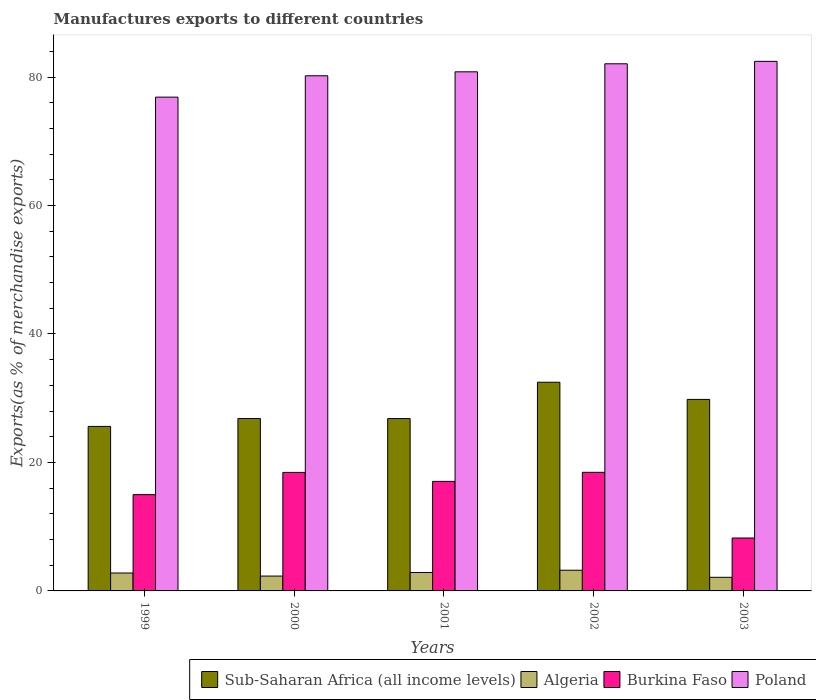Are the number of bars on each tick of the X-axis equal?
Keep it short and to the point. Yes. How many bars are there on the 1st tick from the left?
Ensure brevity in your answer.  4. In how many cases, is the number of bars for a given year not equal to the number of legend labels?
Your answer should be compact. 0. What is the percentage of exports to different countries in Poland in 2003?
Ensure brevity in your answer.  82.44. Across all years, what is the maximum percentage of exports to different countries in Burkina Faso?
Give a very brief answer. 18.46. Across all years, what is the minimum percentage of exports to different countries in Burkina Faso?
Your response must be concise. 8.24. What is the total percentage of exports to different countries in Sub-Saharan Africa (all income levels) in the graph?
Give a very brief answer. 141.58. What is the difference between the percentage of exports to different countries in Sub-Saharan Africa (all income levels) in 2001 and that in 2002?
Your response must be concise. -5.65. What is the difference between the percentage of exports to different countries in Poland in 2000 and the percentage of exports to different countries in Burkina Faso in 2001?
Provide a succinct answer. 63.14. What is the average percentage of exports to different countries in Poland per year?
Make the answer very short. 80.47. In the year 2001, what is the difference between the percentage of exports to different countries in Sub-Saharan Africa (all income levels) and percentage of exports to different countries in Algeria?
Offer a very short reply. 23.96. In how many years, is the percentage of exports to different countries in Poland greater than 28 %?
Offer a terse response. 5. What is the ratio of the percentage of exports to different countries in Poland in 1999 to that in 2003?
Make the answer very short. 0.93. Is the difference between the percentage of exports to different countries in Sub-Saharan Africa (all income levels) in 1999 and 2003 greater than the difference between the percentage of exports to different countries in Algeria in 1999 and 2003?
Ensure brevity in your answer.  No. What is the difference between the highest and the second highest percentage of exports to different countries in Sub-Saharan Africa (all income levels)?
Provide a succinct answer. 2.67. What is the difference between the highest and the lowest percentage of exports to different countries in Poland?
Keep it short and to the point. 5.57. Is the sum of the percentage of exports to different countries in Burkina Faso in 1999 and 2003 greater than the maximum percentage of exports to different countries in Sub-Saharan Africa (all income levels) across all years?
Your response must be concise. No. Is it the case that in every year, the sum of the percentage of exports to different countries in Burkina Faso and percentage of exports to different countries in Algeria is greater than the sum of percentage of exports to different countries in Poland and percentage of exports to different countries in Sub-Saharan Africa (all income levels)?
Keep it short and to the point. Yes. What does the 2nd bar from the left in 2003 represents?
Keep it short and to the point. Algeria. What does the 4th bar from the right in 2001 represents?
Ensure brevity in your answer.  Sub-Saharan Africa (all income levels). Is it the case that in every year, the sum of the percentage of exports to different countries in Sub-Saharan Africa (all income levels) and percentage of exports to different countries in Poland is greater than the percentage of exports to different countries in Burkina Faso?
Ensure brevity in your answer.  Yes. Are all the bars in the graph horizontal?
Your answer should be compact. No. How many years are there in the graph?
Your answer should be very brief. 5. Are the values on the major ticks of Y-axis written in scientific E-notation?
Give a very brief answer. No. Does the graph contain grids?
Keep it short and to the point. No. Where does the legend appear in the graph?
Offer a terse response. Bottom right. How many legend labels are there?
Give a very brief answer. 4. How are the legend labels stacked?
Offer a terse response. Horizontal. What is the title of the graph?
Give a very brief answer. Manufactures exports to different countries. What is the label or title of the Y-axis?
Make the answer very short. Exports(as % of merchandise exports). What is the Exports(as % of merchandise exports) in Sub-Saharan Africa (all income levels) in 1999?
Keep it short and to the point. 25.61. What is the Exports(as % of merchandise exports) in Algeria in 1999?
Offer a terse response. 2.79. What is the Exports(as % of merchandise exports) in Burkina Faso in 1999?
Keep it short and to the point. 14.98. What is the Exports(as % of merchandise exports) in Poland in 1999?
Your answer should be compact. 76.87. What is the Exports(as % of merchandise exports) in Sub-Saharan Africa (all income levels) in 2000?
Your answer should be very brief. 26.84. What is the Exports(as % of merchandise exports) in Algeria in 2000?
Provide a succinct answer. 2.31. What is the Exports(as % of merchandise exports) in Burkina Faso in 2000?
Offer a terse response. 18.45. What is the Exports(as % of merchandise exports) in Poland in 2000?
Your answer should be compact. 80.19. What is the Exports(as % of merchandise exports) of Sub-Saharan Africa (all income levels) in 2001?
Give a very brief answer. 26.83. What is the Exports(as % of merchandise exports) in Algeria in 2001?
Provide a short and direct response. 2.87. What is the Exports(as % of merchandise exports) of Burkina Faso in 2001?
Ensure brevity in your answer.  17.05. What is the Exports(as % of merchandise exports) in Poland in 2001?
Provide a short and direct response. 80.81. What is the Exports(as % of merchandise exports) of Sub-Saharan Africa (all income levels) in 2002?
Offer a terse response. 32.48. What is the Exports(as % of merchandise exports) of Algeria in 2002?
Provide a succinct answer. 3.22. What is the Exports(as % of merchandise exports) in Burkina Faso in 2002?
Offer a terse response. 18.46. What is the Exports(as % of merchandise exports) in Poland in 2002?
Provide a succinct answer. 82.06. What is the Exports(as % of merchandise exports) in Sub-Saharan Africa (all income levels) in 2003?
Ensure brevity in your answer.  29.81. What is the Exports(as % of merchandise exports) of Algeria in 2003?
Your answer should be compact. 2.12. What is the Exports(as % of merchandise exports) in Burkina Faso in 2003?
Offer a terse response. 8.24. What is the Exports(as % of merchandise exports) in Poland in 2003?
Keep it short and to the point. 82.44. Across all years, what is the maximum Exports(as % of merchandise exports) in Sub-Saharan Africa (all income levels)?
Provide a short and direct response. 32.48. Across all years, what is the maximum Exports(as % of merchandise exports) of Algeria?
Offer a terse response. 3.22. Across all years, what is the maximum Exports(as % of merchandise exports) of Burkina Faso?
Ensure brevity in your answer.  18.46. Across all years, what is the maximum Exports(as % of merchandise exports) in Poland?
Offer a terse response. 82.44. Across all years, what is the minimum Exports(as % of merchandise exports) in Sub-Saharan Africa (all income levels)?
Give a very brief answer. 25.61. Across all years, what is the minimum Exports(as % of merchandise exports) of Algeria?
Offer a very short reply. 2.12. Across all years, what is the minimum Exports(as % of merchandise exports) of Burkina Faso?
Keep it short and to the point. 8.24. Across all years, what is the minimum Exports(as % of merchandise exports) of Poland?
Your answer should be very brief. 76.87. What is the total Exports(as % of merchandise exports) of Sub-Saharan Africa (all income levels) in the graph?
Your answer should be compact. 141.58. What is the total Exports(as % of merchandise exports) of Algeria in the graph?
Provide a short and direct response. 13.31. What is the total Exports(as % of merchandise exports) of Burkina Faso in the graph?
Keep it short and to the point. 77.18. What is the total Exports(as % of merchandise exports) in Poland in the graph?
Provide a short and direct response. 402.36. What is the difference between the Exports(as % of merchandise exports) of Sub-Saharan Africa (all income levels) in 1999 and that in 2000?
Ensure brevity in your answer.  -1.24. What is the difference between the Exports(as % of merchandise exports) in Algeria in 1999 and that in 2000?
Ensure brevity in your answer.  0.48. What is the difference between the Exports(as % of merchandise exports) in Burkina Faso in 1999 and that in 2000?
Make the answer very short. -3.46. What is the difference between the Exports(as % of merchandise exports) in Poland in 1999 and that in 2000?
Provide a short and direct response. -3.32. What is the difference between the Exports(as % of merchandise exports) of Sub-Saharan Africa (all income levels) in 1999 and that in 2001?
Your answer should be compact. -1.23. What is the difference between the Exports(as % of merchandise exports) of Algeria in 1999 and that in 2001?
Provide a short and direct response. -0.08. What is the difference between the Exports(as % of merchandise exports) of Burkina Faso in 1999 and that in 2001?
Ensure brevity in your answer.  -2.07. What is the difference between the Exports(as % of merchandise exports) in Poland in 1999 and that in 2001?
Provide a succinct answer. -3.94. What is the difference between the Exports(as % of merchandise exports) in Sub-Saharan Africa (all income levels) in 1999 and that in 2002?
Your response must be concise. -6.88. What is the difference between the Exports(as % of merchandise exports) of Algeria in 1999 and that in 2002?
Give a very brief answer. -0.43. What is the difference between the Exports(as % of merchandise exports) in Burkina Faso in 1999 and that in 2002?
Offer a very short reply. -3.48. What is the difference between the Exports(as % of merchandise exports) of Poland in 1999 and that in 2002?
Provide a succinct answer. -5.19. What is the difference between the Exports(as % of merchandise exports) in Sub-Saharan Africa (all income levels) in 1999 and that in 2003?
Keep it short and to the point. -4.2. What is the difference between the Exports(as % of merchandise exports) of Algeria in 1999 and that in 2003?
Provide a succinct answer. 0.67. What is the difference between the Exports(as % of merchandise exports) in Burkina Faso in 1999 and that in 2003?
Make the answer very short. 6.75. What is the difference between the Exports(as % of merchandise exports) of Poland in 1999 and that in 2003?
Give a very brief answer. -5.57. What is the difference between the Exports(as % of merchandise exports) in Sub-Saharan Africa (all income levels) in 2000 and that in 2001?
Provide a succinct answer. 0.01. What is the difference between the Exports(as % of merchandise exports) of Algeria in 2000 and that in 2001?
Your answer should be compact. -0.56. What is the difference between the Exports(as % of merchandise exports) in Burkina Faso in 2000 and that in 2001?
Provide a succinct answer. 1.4. What is the difference between the Exports(as % of merchandise exports) in Poland in 2000 and that in 2001?
Provide a succinct answer. -0.62. What is the difference between the Exports(as % of merchandise exports) of Sub-Saharan Africa (all income levels) in 2000 and that in 2002?
Provide a succinct answer. -5.64. What is the difference between the Exports(as % of merchandise exports) in Algeria in 2000 and that in 2002?
Your response must be concise. -0.91. What is the difference between the Exports(as % of merchandise exports) in Burkina Faso in 2000 and that in 2002?
Ensure brevity in your answer.  -0.02. What is the difference between the Exports(as % of merchandise exports) of Poland in 2000 and that in 2002?
Provide a succinct answer. -1.87. What is the difference between the Exports(as % of merchandise exports) of Sub-Saharan Africa (all income levels) in 2000 and that in 2003?
Keep it short and to the point. -2.97. What is the difference between the Exports(as % of merchandise exports) of Algeria in 2000 and that in 2003?
Provide a succinct answer. 0.19. What is the difference between the Exports(as % of merchandise exports) of Burkina Faso in 2000 and that in 2003?
Your answer should be compact. 10.21. What is the difference between the Exports(as % of merchandise exports) in Poland in 2000 and that in 2003?
Provide a succinct answer. -2.24. What is the difference between the Exports(as % of merchandise exports) in Sub-Saharan Africa (all income levels) in 2001 and that in 2002?
Keep it short and to the point. -5.65. What is the difference between the Exports(as % of merchandise exports) of Algeria in 2001 and that in 2002?
Keep it short and to the point. -0.35. What is the difference between the Exports(as % of merchandise exports) of Burkina Faso in 2001 and that in 2002?
Keep it short and to the point. -1.41. What is the difference between the Exports(as % of merchandise exports) in Poland in 2001 and that in 2002?
Give a very brief answer. -1.25. What is the difference between the Exports(as % of merchandise exports) of Sub-Saharan Africa (all income levels) in 2001 and that in 2003?
Offer a very short reply. -2.98. What is the difference between the Exports(as % of merchandise exports) of Algeria in 2001 and that in 2003?
Your response must be concise. 0.75. What is the difference between the Exports(as % of merchandise exports) in Burkina Faso in 2001 and that in 2003?
Offer a very short reply. 8.81. What is the difference between the Exports(as % of merchandise exports) of Poland in 2001 and that in 2003?
Offer a very short reply. -1.63. What is the difference between the Exports(as % of merchandise exports) in Sub-Saharan Africa (all income levels) in 2002 and that in 2003?
Your answer should be very brief. 2.67. What is the difference between the Exports(as % of merchandise exports) in Algeria in 2002 and that in 2003?
Make the answer very short. 1.1. What is the difference between the Exports(as % of merchandise exports) of Burkina Faso in 2002 and that in 2003?
Your response must be concise. 10.23. What is the difference between the Exports(as % of merchandise exports) of Poland in 2002 and that in 2003?
Offer a very short reply. -0.38. What is the difference between the Exports(as % of merchandise exports) of Sub-Saharan Africa (all income levels) in 1999 and the Exports(as % of merchandise exports) of Algeria in 2000?
Your answer should be very brief. 23.3. What is the difference between the Exports(as % of merchandise exports) in Sub-Saharan Africa (all income levels) in 1999 and the Exports(as % of merchandise exports) in Burkina Faso in 2000?
Give a very brief answer. 7.16. What is the difference between the Exports(as % of merchandise exports) in Sub-Saharan Africa (all income levels) in 1999 and the Exports(as % of merchandise exports) in Poland in 2000?
Ensure brevity in your answer.  -54.58. What is the difference between the Exports(as % of merchandise exports) of Algeria in 1999 and the Exports(as % of merchandise exports) of Burkina Faso in 2000?
Ensure brevity in your answer.  -15.66. What is the difference between the Exports(as % of merchandise exports) in Algeria in 1999 and the Exports(as % of merchandise exports) in Poland in 2000?
Provide a short and direct response. -77.4. What is the difference between the Exports(as % of merchandise exports) in Burkina Faso in 1999 and the Exports(as % of merchandise exports) in Poland in 2000?
Your response must be concise. -65.21. What is the difference between the Exports(as % of merchandise exports) of Sub-Saharan Africa (all income levels) in 1999 and the Exports(as % of merchandise exports) of Algeria in 2001?
Your answer should be compact. 22.74. What is the difference between the Exports(as % of merchandise exports) of Sub-Saharan Africa (all income levels) in 1999 and the Exports(as % of merchandise exports) of Burkina Faso in 2001?
Offer a terse response. 8.56. What is the difference between the Exports(as % of merchandise exports) in Sub-Saharan Africa (all income levels) in 1999 and the Exports(as % of merchandise exports) in Poland in 2001?
Your answer should be compact. -55.2. What is the difference between the Exports(as % of merchandise exports) in Algeria in 1999 and the Exports(as % of merchandise exports) in Burkina Faso in 2001?
Ensure brevity in your answer.  -14.26. What is the difference between the Exports(as % of merchandise exports) in Algeria in 1999 and the Exports(as % of merchandise exports) in Poland in 2001?
Offer a terse response. -78.02. What is the difference between the Exports(as % of merchandise exports) in Burkina Faso in 1999 and the Exports(as % of merchandise exports) in Poland in 2001?
Your response must be concise. -65.82. What is the difference between the Exports(as % of merchandise exports) of Sub-Saharan Africa (all income levels) in 1999 and the Exports(as % of merchandise exports) of Algeria in 2002?
Your answer should be very brief. 22.39. What is the difference between the Exports(as % of merchandise exports) of Sub-Saharan Africa (all income levels) in 1999 and the Exports(as % of merchandise exports) of Burkina Faso in 2002?
Ensure brevity in your answer.  7.15. What is the difference between the Exports(as % of merchandise exports) in Sub-Saharan Africa (all income levels) in 1999 and the Exports(as % of merchandise exports) in Poland in 2002?
Make the answer very short. -56.45. What is the difference between the Exports(as % of merchandise exports) in Algeria in 1999 and the Exports(as % of merchandise exports) in Burkina Faso in 2002?
Ensure brevity in your answer.  -15.68. What is the difference between the Exports(as % of merchandise exports) in Algeria in 1999 and the Exports(as % of merchandise exports) in Poland in 2002?
Your response must be concise. -79.27. What is the difference between the Exports(as % of merchandise exports) in Burkina Faso in 1999 and the Exports(as % of merchandise exports) in Poland in 2002?
Your response must be concise. -67.07. What is the difference between the Exports(as % of merchandise exports) of Sub-Saharan Africa (all income levels) in 1999 and the Exports(as % of merchandise exports) of Algeria in 2003?
Provide a succinct answer. 23.49. What is the difference between the Exports(as % of merchandise exports) in Sub-Saharan Africa (all income levels) in 1999 and the Exports(as % of merchandise exports) in Burkina Faso in 2003?
Offer a terse response. 17.37. What is the difference between the Exports(as % of merchandise exports) in Sub-Saharan Africa (all income levels) in 1999 and the Exports(as % of merchandise exports) in Poland in 2003?
Offer a very short reply. -56.83. What is the difference between the Exports(as % of merchandise exports) in Algeria in 1999 and the Exports(as % of merchandise exports) in Burkina Faso in 2003?
Give a very brief answer. -5.45. What is the difference between the Exports(as % of merchandise exports) of Algeria in 1999 and the Exports(as % of merchandise exports) of Poland in 2003?
Make the answer very short. -79.65. What is the difference between the Exports(as % of merchandise exports) in Burkina Faso in 1999 and the Exports(as % of merchandise exports) in Poland in 2003?
Ensure brevity in your answer.  -67.45. What is the difference between the Exports(as % of merchandise exports) in Sub-Saharan Africa (all income levels) in 2000 and the Exports(as % of merchandise exports) in Algeria in 2001?
Provide a succinct answer. 23.97. What is the difference between the Exports(as % of merchandise exports) of Sub-Saharan Africa (all income levels) in 2000 and the Exports(as % of merchandise exports) of Burkina Faso in 2001?
Keep it short and to the point. 9.79. What is the difference between the Exports(as % of merchandise exports) of Sub-Saharan Africa (all income levels) in 2000 and the Exports(as % of merchandise exports) of Poland in 2001?
Your answer should be compact. -53.96. What is the difference between the Exports(as % of merchandise exports) in Algeria in 2000 and the Exports(as % of merchandise exports) in Burkina Faso in 2001?
Offer a terse response. -14.74. What is the difference between the Exports(as % of merchandise exports) in Algeria in 2000 and the Exports(as % of merchandise exports) in Poland in 2001?
Keep it short and to the point. -78.5. What is the difference between the Exports(as % of merchandise exports) in Burkina Faso in 2000 and the Exports(as % of merchandise exports) in Poland in 2001?
Give a very brief answer. -62.36. What is the difference between the Exports(as % of merchandise exports) of Sub-Saharan Africa (all income levels) in 2000 and the Exports(as % of merchandise exports) of Algeria in 2002?
Your answer should be very brief. 23.62. What is the difference between the Exports(as % of merchandise exports) in Sub-Saharan Africa (all income levels) in 2000 and the Exports(as % of merchandise exports) in Burkina Faso in 2002?
Give a very brief answer. 8.38. What is the difference between the Exports(as % of merchandise exports) of Sub-Saharan Africa (all income levels) in 2000 and the Exports(as % of merchandise exports) of Poland in 2002?
Offer a very short reply. -55.21. What is the difference between the Exports(as % of merchandise exports) in Algeria in 2000 and the Exports(as % of merchandise exports) in Burkina Faso in 2002?
Offer a very short reply. -16.15. What is the difference between the Exports(as % of merchandise exports) in Algeria in 2000 and the Exports(as % of merchandise exports) in Poland in 2002?
Ensure brevity in your answer.  -79.75. What is the difference between the Exports(as % of merchandise exports) of Burkina Faso in 2000 and the Exports(as % of merchandise exports) of Poland in 2002?
Offer a very short reply. -63.61. What is the difference between the Exports(as % of merchandise exports) in Sub-Saharan Africa (all income levels) in 2000 and the Exports(as % of merchandise exports) in Algeria in 2003?
Keep it short and to the point. 24.73. What is the difference between the Exports(as % of merchandise exports) in Sub-Saharan Africa (all income levels) in 2000 and the Exports(as % of merchandise exports) in Burkina Faso in 2003?
Provide a short and direct response. 18.61. What is the difference between the Exports(as % of merchandise exports) in Sub-Saharan Africa (all income levels) in 2000 and the Exports(as % of merchandise exports) in Poland in 2003?
Your response must be concise. -55.59. What is the difference between the Exports(as % of merchandise exports) of Algeria in 2000 and the Exports(as % of merchandise exports) of Burkina Faso in 2003?
Keep it short and to the point. -5.92. What is the difference between the Exports(as % of merchandise exports) of Algeria in 2000 and the Exports(as % of merchandise exports) of Poland in 2003?
Your response must be concise. -80.12. What is the difference between the Exports(as % of merchandise exports) of Burkina Faso in 2000 and the Exports(as % of merchandise exports) of Poland in 2003?
Make the answer very short. -63.99. What is the difference between the Exports(as % of merchandise exports) of Sub-Saharan Africa (all income levels) in 2001 and the Exports(as % of merchandise exports) of Algeria in 2002?
Offer a terse response. 23.61. What is the difference between the Exports(as % of merchandise exports) of Sub-Saharan Africa (all income levels) in 2001 and the Exports(as % of merchandise exports) of Burkina Faso in 2002?
Offer a terse response. 8.37. What is the difference between the Exports(as % of merchandise exports) in Sub-Saharan Africa (all income levels) in 2001 and the Exports(as % of merchandise exports) in Poland in 2002?
Give a very brief answer. -55.23. What is the difference between the Exports(as % of merchandise exports) of Algeria in 2001 and the Exports(as % of merchandise exports) of Burkina Faso in 2002?
Offer a terse response. -15.59. What is the difference between the Exports(as % of merchandise exports) of Algeria in 2001 and the Exports(as % of merchandise exports) of Poland in 2002?
Provide a succinct answer. -79.19. What is the difference between the Exports(as % of merchandise exports) in Burkina Faso in 2001 and the Exports(as % of merchandise exports) in Poland in 2002?
Provide a short and direct response. -65.01. What is the difference between the Exports(as % of merchandise exports) of Sub-Saharan Africa (all income levels) in 2001 and the Exports(as % of merchandise exports) of Algeria in 2003?
Provide a short and direct response. 24.71. What is the difference between the Exports(as % of merchandise exports) in Sub-Saharan Africa (all income levels) in 2001 and the Exports(as % of merchandise exports) in Burkina Faso in 2003?
Provide a short and direct response. 18.6. What is the difference between the Exports(as % of merchandise exports) of Sub-Saharan Africa (all income levels) in 2001 and the Exports(as % of merchandise exports) of Poland in 2003?
Keep it short and to the point. -55.6. What is the difference between the Exports(as % of merchandise exports) in Algeria in 2001 and the Exports(as % of merchandise exports) in Burkina Faso in 2003?
Your answer should be compact. -5.37. What is the difference between the Exports(as % of merchandise exports) of Algeria in 2001 and the Exports(as % of merchandise exports) of Poland in 2003?
Your response must be concise. -79.57. What is the difference between the Exports(as % of merchandise exports) of Burkina Faso in 2001 and the Exports(as % of merchandise exports) of Poland in 2003?
Your answer should be compact. -65.39. What is the difference between the Exports(as % of merchandise exports) in Sub-Saharan Africa (all income levels) in 2002 and the Exports(as % of merchandise exports) in Algeria in 2003?
Offer a very short reply. 30.36. What is the difference between the Exports(as % of merchandise exports) of Sub-Saharan Africa (all income levels) in 2002 and the Exports(as % of merchandise exports) of Burkina Faso in 2003?
Offer a terse response. 24.25. What is the difference between the Exports(as % of merchandise exports) in Sub-Saharan Africa (all income levels) in 2002 and the Exports(as % of merchandise exports) in Poland in 2003?
Your answer should be compact. -49.95. What is the difference between the Exports(as % of merchandise exports) of Algeria in 2002 and the Exports(as % of merchandise exports) of Burkina Faso in 2003?
Offer a very short reply. -5.02. What is the difference between the Exports(as % of merchandise exports) in Algeria in 2002 and the Exports(as % of merchandise exports) in Poland in 2003?
Offer a terse response. -79.22. What is the difference between the Exports(as % of merchandise exports) of Burkina Faso in 2002 and the Exports(as % of merchandise exports) of Poland in 2003?
Keep it short and to the point. -63.97. What is the average Exports(as % of merchandise exports) of Sub-Saharan Africa (all income levels) per year?
Keep it short and to the point. 28.32. What is the average Exports(as % of merchandise exports) in Algeria per year?
Your answer should be very brief. 2.66. What is the average Exports(as % of merchandise exports) of Burkina Faso per year?
Your response must be concise. 15.44. What is the average Exports(as % of merchandise exports) of Poland per year?
Make the answer very short. 80.47. In the year 1999, what is the difference between the Exports(as % of merchandise exports) of Sub-Saharan Africa (all income levels) and Exports(as % of merchandise exports) of Algeria?
Ensure brevity in your answer.  22.82. In the year 1999, what is the difference between the Exports(as % of merchandise exports) of Sub-Saharan Africa (all income levels) and Exports(as % of merchandise exports) of Burkina Faso?
Provide a short and direct response. 10.62. In the year 1999, what is the difference between the Exports(as % of merchandise exports) in Sub-Saharan Africa (all income levels) and Exports(as % of merchandise exports) in Poland?
Give a very brief answer. -51.26. In the year 1999, what is the difference between the Exports(as % of merchandise exports) in Algeria and Exports(as % of merchandise exports) in Burkina Faso?
Offer a terse response. -12.2. In the year 1999, what is the difference between the Exports(as % of merchandise exports) in Algeria and Exports(as % of merchandise exports) in Poland?
Give a very brief answer. -74.08. In the year 1999, what is the difference between the Exports(as % of merchandise exports) of Burkina Faso and Exports(as % of merchandise exports) of Poland?
Provide a short and direct response. -61.88. In the year 2000, what is the difference between the Exports(as % of merchandise exports) in Sub-Saharan Africa (all income levels) and Exports(as % of merchandise exports) in Algeria?
Your answer should be compact. 24.53. In the year 2000, what is the difference between the Exports(as % of merchandise exports) of Sub-Saharan Africa (all income levels) and Exports(as % of merchandise exports) of Burkina Faso?
Offer a terse response. 8.4. In the year 2000, what is the difference between the Exports(as % of merchandise exports) in Sub-Saharan Africa (all income levels) and Exports(as % of merchandise exports) in Poland?
Keep it short and to the point. -53.35. In the year 2000, what is the difference between the Exports(as % of merchandise exports) of Algeria and Exports(as % of merchandise exports) of Burkina Faso?
Keep it short and to the point. -16.14. In the year 2000, what is the difference between the Exports(as % of merchandise exports) in Algeria and Exports(as % of merchandise exports) in Poland?
Make the answer very short. -77.88. In the year 2000, what is the difference between the Exports(as % of merchandise exports) in Burkina Faso and Exports(as % of merchandise exports) in Poland?
Ensure brevity in your answer.  -61.74. In the year 2001, what is the difference between the Exports(as % of merchandise exports) in Sub-Saharan Africa (all income levels) and Exports(as % of merchandise exports) in Algeria?
Provide a succinct answer. 23.96. In the year 2001, what is the difference between the Exports(as % of merchandise exports) of Sub-Saharan Africa (all income levels) and Exports(as % of merchandise exports) of Burkina Faso?
Your answer should be very brief. 9.78. In the year 2001, what is the difference between the Exports(as % of merchandise exports) in Sub-Saharan Africa (all income levels) and Exports(as % of merchandise exports) in Poland?
Your answer should be very brief. -53.98. In the year 2001, what is the difference between the Exports(as % of merchandise exports) of Algeria and Exports(as % of merchandise exports) of Burkina Faso?
Keep it short and to the point. -14.18. In the year 2001, what is the difference between the Exports(as % of merchandise exports) of Algeria and Exports(as % of merchandise exports) of Poland?
Offer a terse response. -77.94. In the year 2001, what is the difference between the Exports(as % of merchandise exports) in Burkina Faso and Exports(as % of merchandise exports) in Poland?
Your answer should be very brief. -63.76. In the year 2002, what is the difference between the Exports(as % of merchandise exports) of Sub-Saharan Africa (all income levels) and Exports(as % of merchandise exports) of Algeria?
Provide a succinct answer. 29.26. In the year 2002, what is the difference between the Exports(as % of merchandise exports) of Sub-Saharan Africa (all income levels) and Exports(as % of merchandise exports) of Burkina Faso?
Your answer should be very brief. 14.02. In the year 2002, what is the difference between the Exports(as % of merchandise exports) of Sub-Saharan Africa (all income levels) and Exports(as % of merchandise exports) of Poland?
Your answer should be very brief. -49.57. In the year 2002, what is the difference between the Exports(as % of merchandise exports) of Algeria and Exports(as % of merchandise exports) of Burkina Faso?
Offer a very short reply. -15.24. In the year 2002, what is the difference between the Exports(as % of merchandise exports) of Algeria and Exports(as % of merchandise exports) of Poland?
Offer a very short reply. -78.84. In the year 2002, what is the difference between the Exports(as % of merchandise exports) of Burkina Faso and Exports(as % of merchandise exports) of Poland?
Your answer should be very brief. -63.6. In the year 2003, what is the difference between the Exports(as % of merchandise exports) of Sub-Saharan Africa (all income levels) and Exports(as % of merchandise exports) of Algeria?
Your answer should be very brief. 27.69. In the year 2003, what is the difference between the Exports(as % of merchandise exports) of Sub-Saharan Africa (all income levels) and Exports(as % of merchandise exports) of Burkina Faso?
Your answer should be very brief. 21.58. In the year 2003, what is the difference between the Exports(as % of merchandise exports) in Sub-Saharan Africa (all income levels) and Exports(as % of merchandise exports) in Poland?
Your answer should be very brief. -52.62. In the year 2003, what is the difference between the Exports(as % of merchandise exports) of Algeria and Exports(as % of merchandise exports) of Burkina Faso?
Give a very brief answer. -6.12. In the year 2003, what is the difference between the Exports(as % of merchandise exports) in Algeria and Exports(as % of merchandise exports) in Poland?
Provide a succinct answer. -80.32. In the year 2003, what is the difference between the Exports(as % of merchandise exports) in Burkina Faso and Exports(as % of merchandise exports) in Poland?
Your answer should be very brief. -74.2. What is the ratio of the Exports(as % of merchandise exports) in Sub-Saharan Africa (all income levels) in 1999 to that in 2000?
Offer a terse response. 0.95. What is the ratio of the Exports(as % of merchandise exports) of Algeria in 1999 to that in 2000?
Keep it short and to the point. 1.21. What is the ratio of the Exports(as % of merchandise exports) of Burkina Faso in 1999 to that in 2000?
Your response must be concise. 0.81. What is the ratio of the Exports(as % of merchandise exports) of Poland in 1999 to that in 2000?
Make the answer very short. 0.96. What is the ratio of the Exports(as % of merchandise exports) of Sub-Saharan Africa (all income levels) in 1999 to that in 2001?
Offer a terse response. 0.95. What is the ratio of the Exports(as % of merchandise exports) in Algeria in 1999 to that in 2001?
Your answer should be very brief. 0.97. What is the ratio of the Exports(as % of merchandise exports) in Burkina Faso in 1999 to that in 2001?
Provide a succinct answer. 0.88. What is the ratio of the Exports(as % of merchandise exports) in Poland in 1999 to that in 2001?
Ensure brevity in your answer.  0.95. What is the ratio of the Exports(as % of merchandise exports) of Sub-Saharan Africa (all income levels) in 1999 to that in 2002?
Ensure brevity in your answer.  0.79. What is the ratio of the Exports(as % of merchandise exports) in Algeria in 1999 to that in 2002?
Make the answer very short. 0.87. What is the ratio of the Exports(as % of merchandise exports) in Burkina Faso in 1999 to that in 2002?
Ensure brevity in your answer.  0.81. What is the ratio of the Exports(as % of merchandise exports) in Poland in 1999 to that in 2002?
Provide a short and direct response. 0.94. What is the ratio of the Exports(as % of merchandise exports) of Sub-Saharan Africa (all income levels) in 1999 to that in 2003?
Provide a succinct answer. 0.86. What is the ratio of the Exports(as % of merchandise exports) of Algeria in 1999 to that in 2003?
Provide a succinct answer. 1.32. What is the ratio of the Exports(as % of merchandise exports) of Burkina Faso in 1999 to that in 2003?
Offer a terse response. 1.82. What is the ratio of the Exports(as % of merchandise exports) in Poland in 1999 to that in 2003?
Provide a succinct answer. 0.93. What is the ratio of the Exports(as % of merchandise exports) in Sub-Saharan Africa (all income levels) in 2000 to that in 2001?
Make the answer very short. 1. What is the ratio of the Exports(as % of merchandise exports) in Algeria in 2000 to that in 2001?
Offer a very short reply. 0.81. What is the ratio of the Exports(as % of merchandise exports) of Burkina Faso in 2000 to that in 2001?
Your response must be concise. 1.08. What is the ratio of the Exports(as % of merchandise exports) in Poland in 2000 to that in 2001?
Make the answer very short. 0.99. What is the ratio of the Exports(as % of merchandise exports) in Sub-Saharan Africa (all income levels) in 2000 to that in 2002?
Offer a terse response. 0.83. What is the ratio of the Exports(as % of merchandise exports) in Algeria in 2000 to that in 2002?
Your response must be concise. 0.72. What is the ratio of the Exports(as % of merchandise exports) of Burkina Faso in 2000 to that in 2002?
Your response must be concise. 1. What is the ratio of the Exports(as % of merchandise exports) in Poland in 2000 to that in 2002?
Your answer should be very brief. 0.98. What is the ratio of the Exports(as % of merchandise exports) of Sub-Saharan Africa (all income levels) in 2000 to that in 2003?
Keep it short and to the point. 0.9. What is the ratio of the Exports(as % of merchandise exports) in Algeria in 2000 to that in 2003?
Your answer should be very brief. 1.09. What is the ratio of the Exports(as % of merchandise exports) in Burkina Faso in 2000 to that in 2003?
Make the answer very short. 2.24. What is the ratio of the Exports(as % of merchandise exports) of Poland in 2000 to that in 2003?
Your answer should be compact. 0.97. What is the ratio of the Exports(as % of merchandise exports) of Sub-Saharan Africa (all income levels) in 2001 to that in 2002?
Offer a terse response. 0.83. What is the ratio of the Exports(as % of merchandise exports) in Algeria in 2001 to that in 2002?
Your answer should be compact. 0.89. What is the ratio of the Exports(as % of merchandise exports) in Burkina Faso in 2001 to that in 2002?
Provide a succinct answer. 0.92. What is the ratio of the Exports(as % of merchandise exports) in Poland in 2001 to that in 2002?
Offer a very short reply. 0.98. What is the ratio of the Exports(as % of merchandise exports) of Sub-Saharan Africa (all income levels) in 2001 to that in 2003?
Give a very brief answer. 0.9. What is the ratio of the Exports(as % of merchandise exports) of Algeria in 2001 to that in 2003?
Your answer should be very brief. 1.35. What is the ratio of the Exports(as % of merchandise exports) in Burkina Faso in 2001 to that in 2003?
Provide a succinct answer. 2.07. What is the ratio of the Exports(as % of merchandise exports) in Poland in 2001 to that in 2003?
Provide a short and direct response. 0.98. What is the ratio of the Exports(as % of merchandise exports) in Sub-Saharan Africa (all income levels) in 2002 to that in 2003?
Give a very brief answer. 1.09. What is the ratio of the Exports(as % of merchandise exports) of Algeria in 2002 to that in 2003?
Your response must be concise. 1.52. What is the ratio of the Exports(as % of merchandise exports) of Burkina Faso in 2002 to that in 2003?
Provide a short and direct response. 2.24. What is the difference between the highest and the second highest Exports(as % of merchandise exports) in Sub-Saharan Africa (all income levels)?
Provide a short and direct response. 2.67. What is the difference between the highest and the second highest Exports(as % of merchandise exports) of Algeria?
Offer a terse response. 0.35. What is the difference between the highest and the second highest Exports(as % of merchandise exports) in Burkina Faso?
Give a very brief answer. 0.02. What is the difference between the highest and the second highest Exports(as % of merchandise exports) in Poland?
Offer a terse response. 0.38. What is the difference between the highest and the lowest Exports(as % of merchandise exports) in Sub-Saharan Africa (all income levels)?
Offer a very short reply. 6.88. What is the difference between the highest and the lowest Exports(as % of merchandise exports) in Algeria?
Offer a very short reply. 1.1. What is the difference between the highest and the lowest Exports(as % of merchandise exports) in Burkina Faso?
Give a very brief answer. 10.23. What is the difference between the highest and the lowest Exports(as % of merchandise exports) of Poland?
Offer a very short reply. 5.57. 